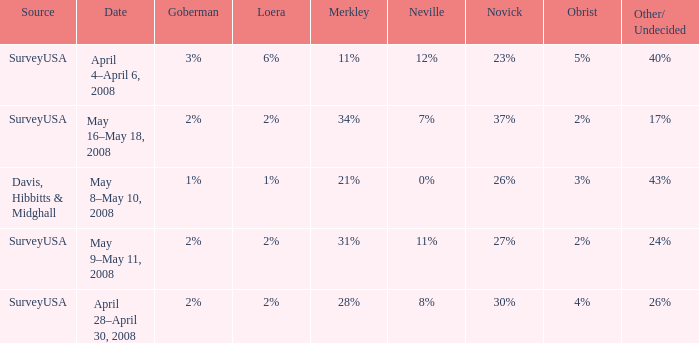Which Date has a Novick of 26%? May 8–May 10, 2008. 